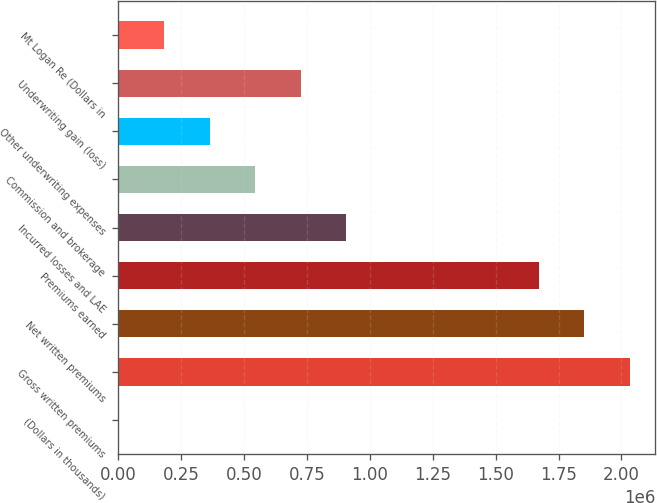Convert chart to OTSL. <chart><loc_0><loc_0><loc_500><loc_500><bar_chart><fcel>(Dollars in thousands)<fcel>Gross written premiums<fcel>Net written premiums<fcel>Premiums earned<fcel>Incurred losses and LAE<fcel>Commission and brokerage<fcel>Other underwriting expenses<fcel>Underwriting gain (loss)<fcel>Mt Logan Re (Dollars in<nl><fcel>2013<fcel>2.03304e+06<fcel>1.85228e+06<fcel>1.67151e+06<fcel>905841<fcel>544310<fcel>363544<fcel>725075<fcel>182779<nl></chart> 